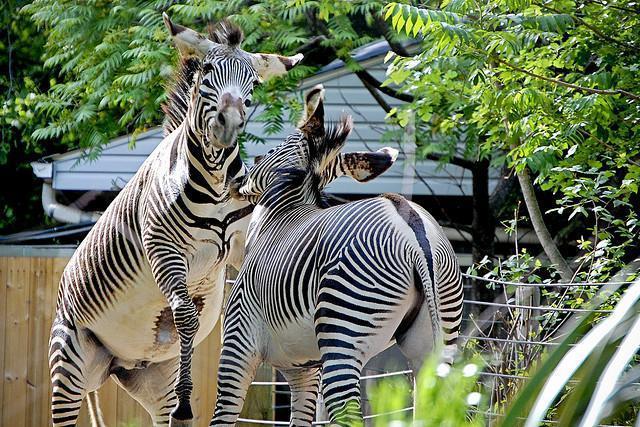How many zebras are visible?
Give a very brief answer. 2. 